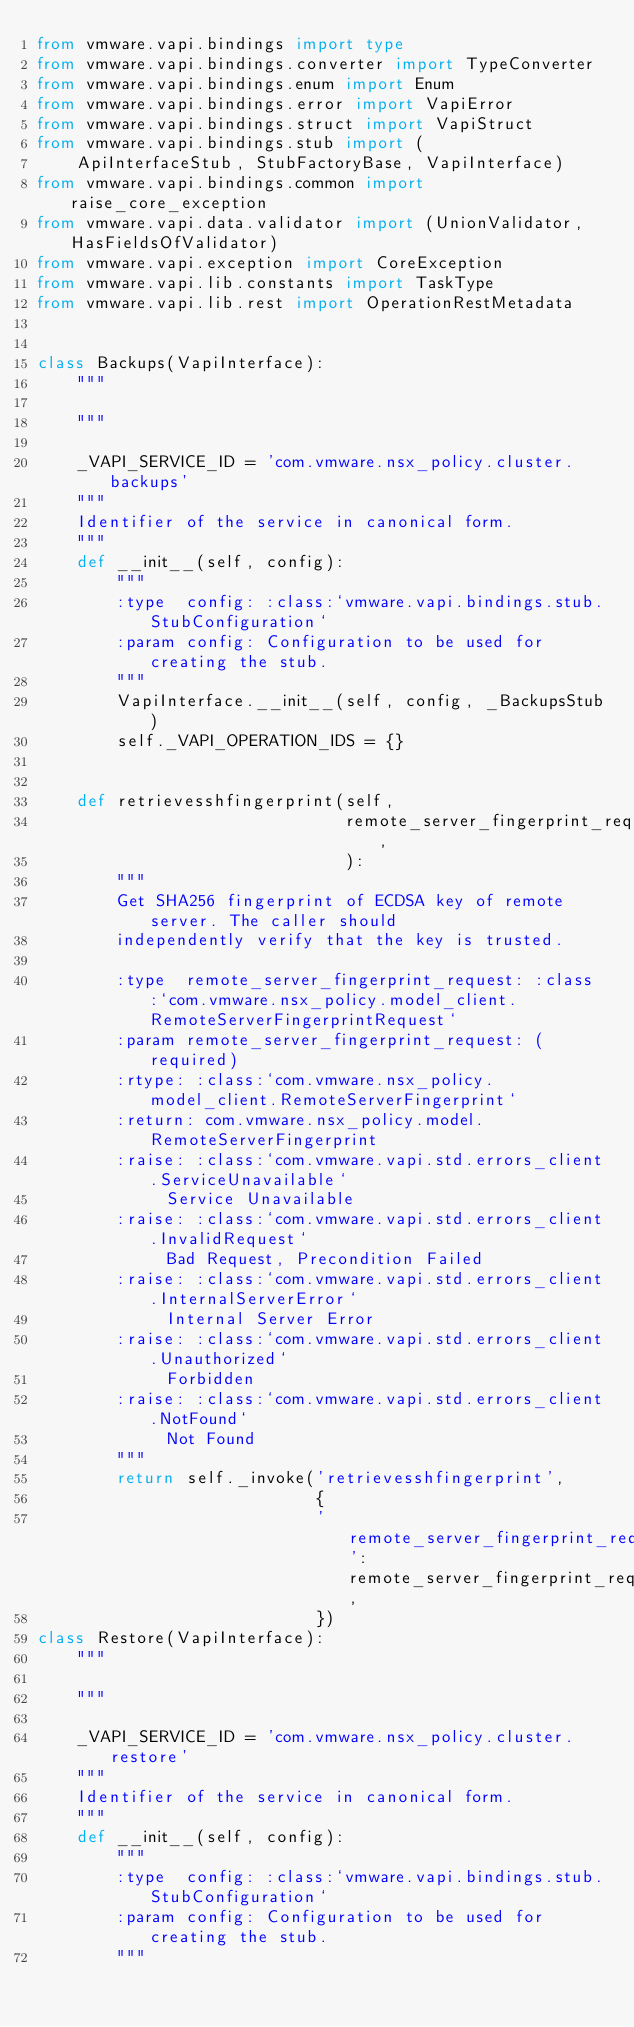Convert code to text. <code><loc_0><loc_0><loc_500><loc_500><_Python_>from vmware.vapi.bindings import type
from vmware.vapi.bindings.converter import TypeConverter
from vmware.vapi.bindings.enum import Enum
from vmware.vapi.bindings.error import VapiError
from vmware.vapi.bindings.struct import VapiStruct
from vmware.vapi.bindings.stub import (
    ApiInterfaceStub, StubFactoryBase, VapiInterface)
from vmware.vapi.bindings.common import raise_core_exception
from vmware.vapi.data.validator import (UnionValidator, HasFieldsOfValidator)
from vmware.vapi.exception import CoreException
from vmware.vapi.lib.constants import TaskType
from vmware.vapi.lib.rest import OperationRestMetadata


class Backups(VapiInterface):
    """
    
    """

    _VAPI_SERVICE_ID = 'com.vmware.nsx_policy.cluster.backups'
    """
    Identifier of the service in canonical form.
    """
    def __init__(self, config):
        """
        :type  config: :class:`vmware.vapi.bindings.stub.StubConfiguration`
        :param config: Configuration to be used for creating the stub.
        """
        VapiInterface.__init__(self, config, _BackupsStub)
        self._VAPI_OPERATION_IDS = {}


    def retrievesshfingerprint(self,
                               remote_server_fingerprint_request,
                               ):
        """
        Get SHA256 fingerprint of ECDSA key of remote server. The caller should
        independently verify that the key is trusted.

        :type  remote_server_fingerprint_request: :class:`com.vmware.nsx_policy.model_client.RemoteServerFingerprintRequest`
        :param remote_server_fingerprint_request: (required)
        :rtype: :class:`com.vmware.nsx_policy.model_client.RemoteServerFingerprint`
        :return: com.vmware.nsx_policy.model.RemoteServerFingerprint
        :raise: :class:`com.vmware.vapi.std.errors_client.ServiceUnavailable` 
             Service Unavailable
        :raise: :class:`com.vmware.vapi.std.errors_client.InvalidRequest` 
             Bad Request, Precondition Failed
        :raise: :class:`com.vmware.vapi.std.errors_client.InternalServerError` 
             Internal Server Error
        :raise: :class:`com.vmware.vapi.std.errors_client.Unauthorized` 
             Forbidden
        :raise: :class:`com.vmware.vapi.std.errors_client.NotFound` 
             Not Found
        """
        return self._invoke('retrievesshfingerprint',
                            {
                            'remote_server_fingerprint_request': remote_server_fingerprint_request,
                            })
class Restore(VapiInterface):
    """
    
    """

    _VAPI_SERVICE_ID = 'com.vmware.nsx_policy.cluster.restore'
    """
    Identifier of the service in canonical form.
    """
    def __init__(self, config):
        """
        :type  config: :class:`vmware.vapi.bindings.stub.StubConfiguration`
        :param config: Configuration to be used for creating the stub.
        """</code> 